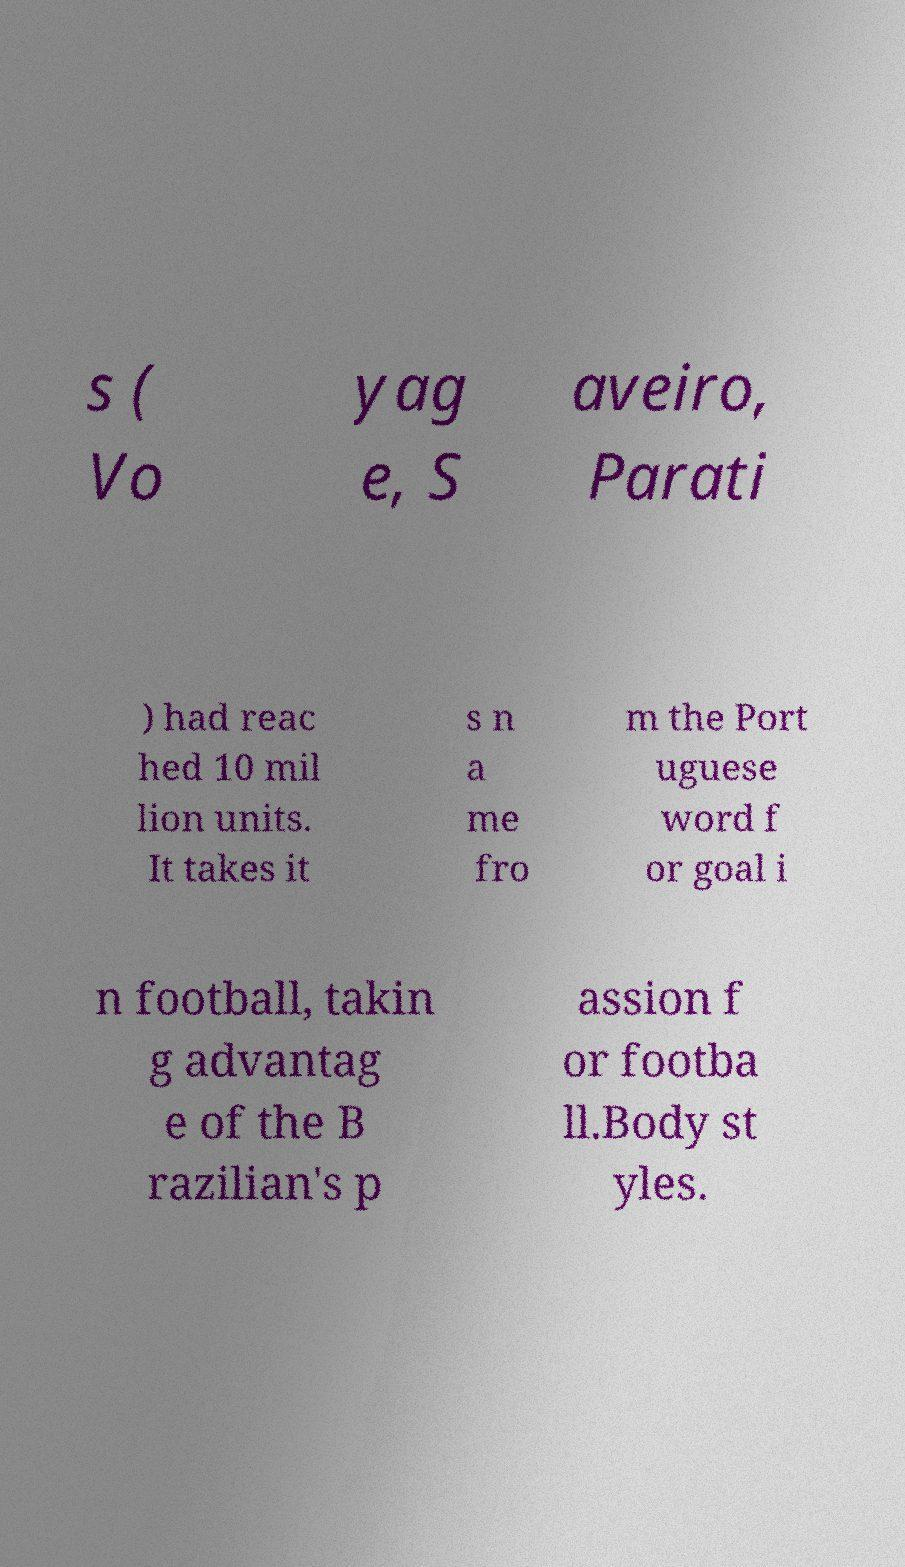What messages or text are displayed in this image? I need them in a readable, typed format. s ( Vo yag e, S aveiro, Parati ) had reac hed 10 mil lion units. It takes it s n a me fro m the Port uguese word f or goal i n football, takin g advantag e of the B razilian's p assion f or footba ll.Body st yles. 